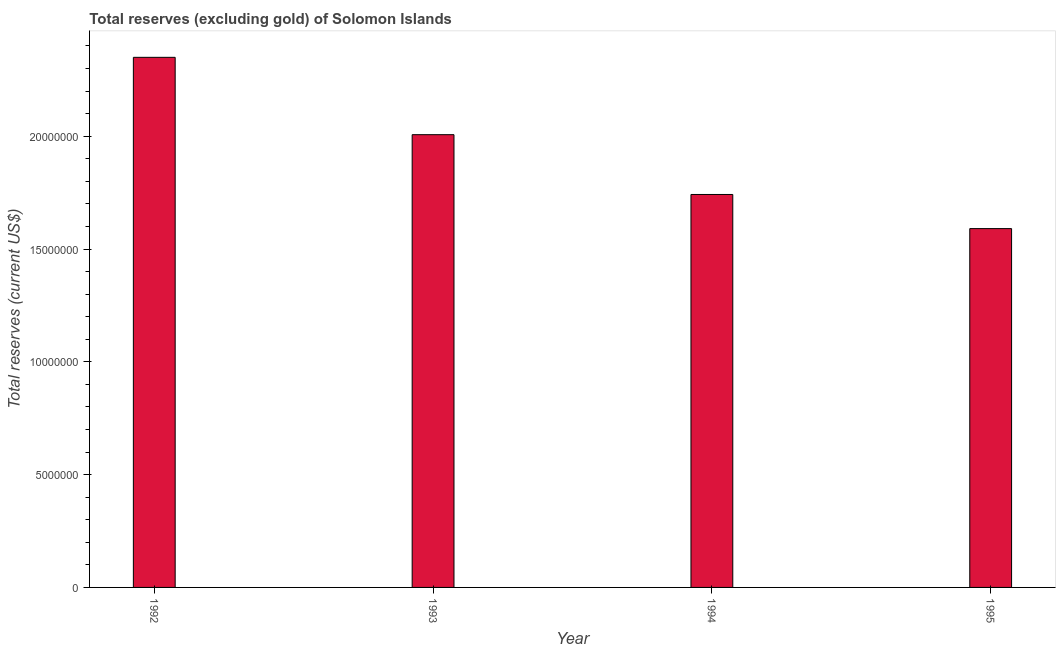Does the graph contain any zero values?
Provide a short and direct response. No. What is the title of the graph?
Provide a succinct answer. Total reserves (excluding gold) of Solomon Islands. What is the label or title of the X-axis?
Your answer should be very brief. Year. What is the label or title of the Y-axis?
Keep it short and to the point. Total reserves (current US$). What is the total reserves (excluding gold) in 1995?
Provide a short and direct response. 1.59e+07. Across all years, what is the maximum total reserves (excluding gold)?
Offer a terse response. 2.35e+07. Across all years, what is the minimum total reserves (excluding gold)?
Offer a terse response. 1.59e+07. In which year was the total reserves (excluding gold) maximum?
Your answer should be compact. 1992. What is the sum of the total reserves (excluding gold)?
Provide a short and direct response. 7.69e+07. What is the difference between the total reserves (excluding gold) in 1994 and 1995?
Ensure brevity in your answer.  1.51e+06. What is the average total reserves (excluding gold) per year?
Your answer should be compact. 1.92e+07. What is the median total reserves (excluding gold)?
Keep it short and to the point. 1.87e+07. In how many years, is the total reserves (excluding gold) greater than 21000000 US$?
Your answer should be compact. 1. What is the ratio of the total reserves (excluding gold) in 1993 to that in 1995?
Your answer should be very brief. 1.26. Is the total reserves (excluding gold) in 1994 less than that in 1995?
Your answer should be very brief. No. What is the difference between the highest and the second highest total reserves (excluding gold)?
Provide a short and direct response. 3.43e+06. What is the difference between the highest and the lowest total reserves (excluding gold)?
Provide a succinct answer. 7.59e+06. Are all the bars in the graph horizontal?
Your response must be concise. No. How many years are there in the graph?
Ensure brevity in your answer.  4. What is the difference between two consecutive major ticks on the Y-axis?
Keep it short and to the point. 5.00e+06. What is the Total reserves (current US$) of 1992?
Keep it short and to the point. 2.35e+07. What is the Total reserves (current US$) in 1993?
Your answer should be very brief. 2.01e+07. What is the Total reserves (current US$) in 1994?
Provide a short and direct response. 1.74e+07. What is the Total reserves (current US$) in 1995?
Offer a very short reply. 1.59e+07. What is the difference between the Total reserves (current US$) in 1992 and 1993?
Offer a terse response. 3.43e+06. What is the difference between the Total reserves (current US$) in 1992 and 1994?
Ensure brevity in your answer.  6.08e+06. What is the difference between the Total reserves (current US$) in 1992 and 1995?
Give a very brief answer. 7.59e+06. What is the difference between the Total reserves (current US$) in 1993 and 1994?
Provide a short and direct response. 2.65e+06. What is the difference between the Total reserves (current US$) in 1993 and 1995?
Offer a terse response. 4.16e+06. What is the difference between the Total reserves (current US$) in 1994 and 1995?
Your answer should be compact. 1.51e+06. What is the ratio of the Total reserves (current US$) in 1992 to that in 1993?
Offer a terse response. 1.17. What is the ratio of the Total reserves (current US$) in 1992 to that in 1994?
Offer a very short reply. 1.35. What is the ratio of the Total reserves (current US$) in 1992 to that in 1995?
Offer a terse response. 1.48. What is the ratio of the Total reserves (current US$) in 1993 to that in 1994?
Your answer should be very brief. 1.15. What is the ratio of the Total reserves (current US$) in 1993 to that in 1995?
Make the answer very short. 1.26. What is the ratio of the Total reserves (current US$) in 1994 to that in 1995?
Provide a succinct answer. 1.09. 